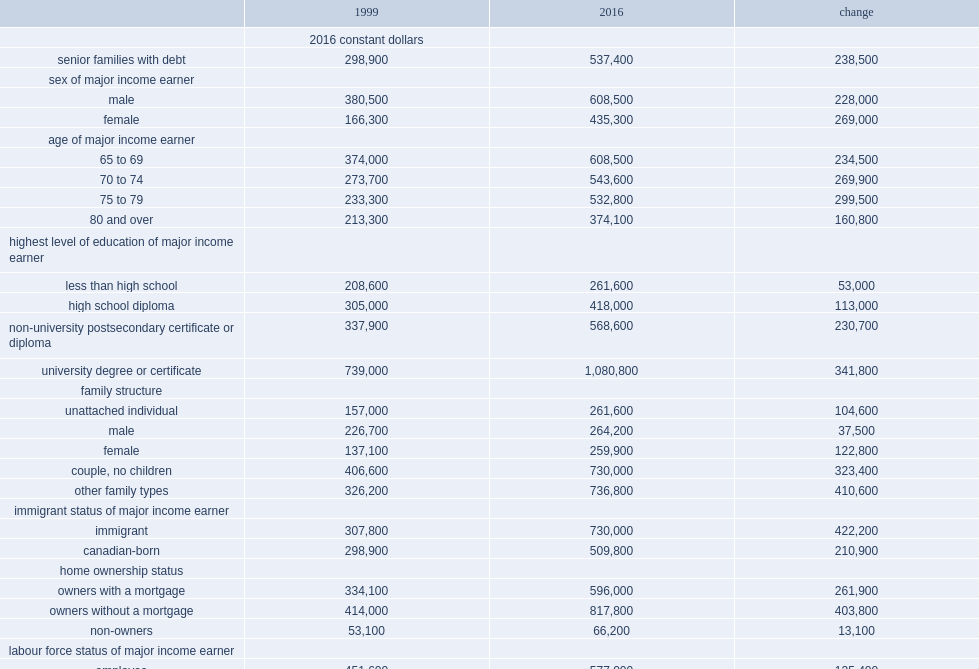How much(dollars) was the median net worth of senior families with debt in 2016? 537400.0. List the top 2 families with the largest increases. Fourth quintile top quintile. 